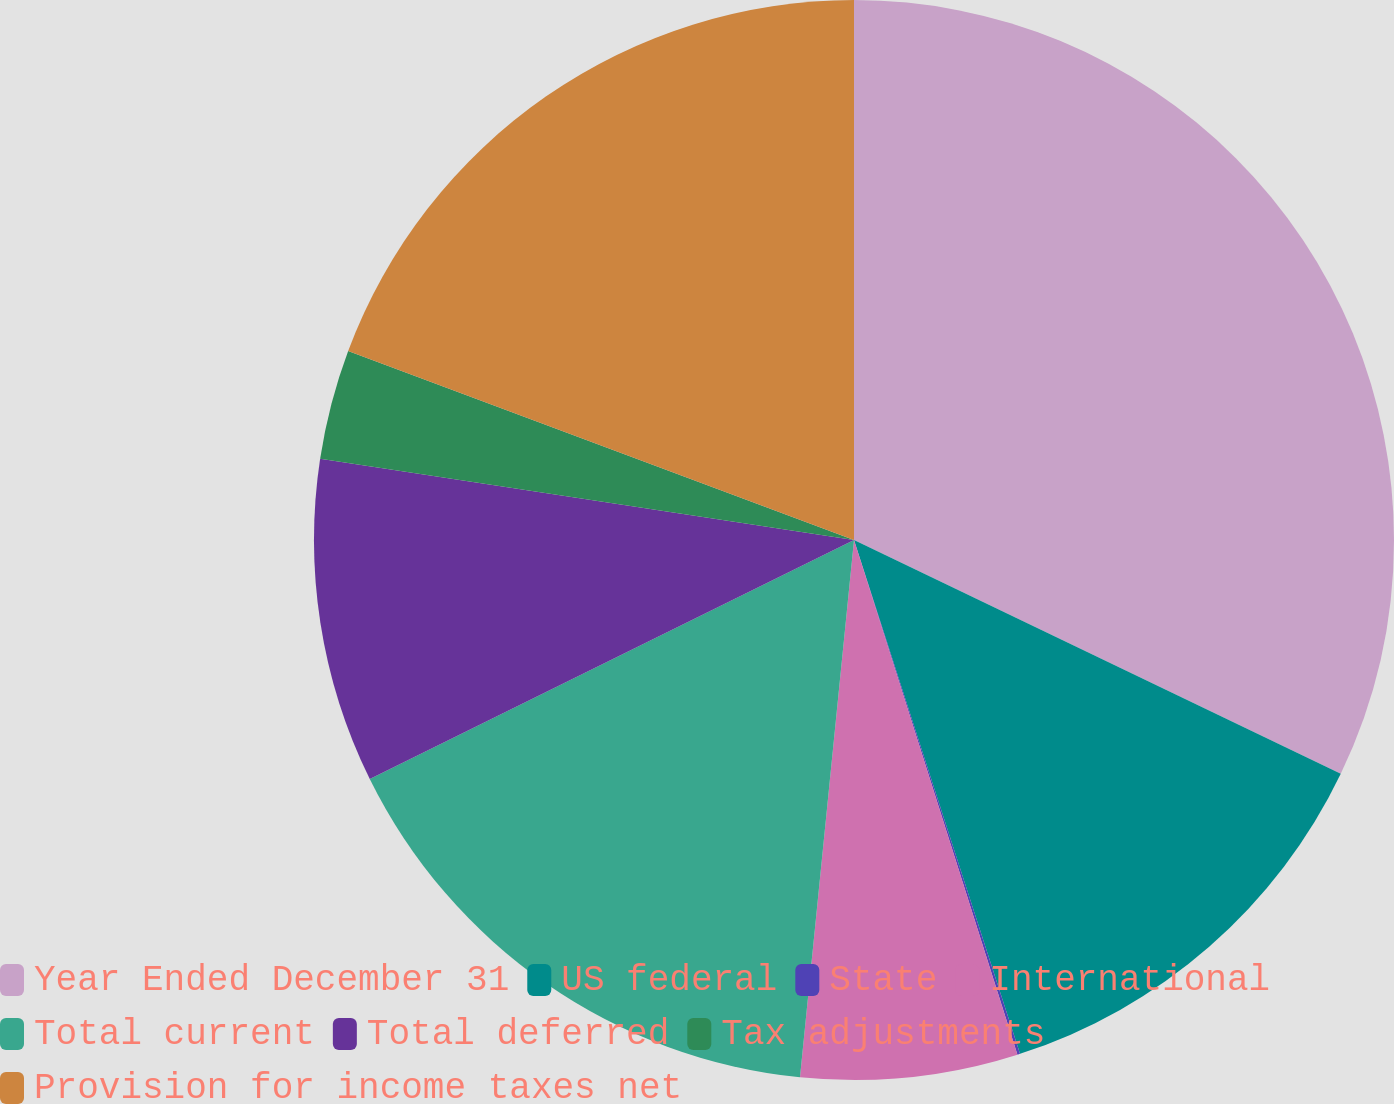Convert chart. <chart><loc_0><loc_0><loc_500><loc_500><pie_chart><fcel>Year Ended December 31<fcel>US federal<fcel>State<fcel>International<fcel>Total current<fcel>Total deferred<fcel>Tax adjustments<fcel>Provision for income taxes net<nl><fcel>32.13%<fcel>12.9%<fcel>0.08%<fcel>6.49%<fcel>16.11%<fcel>9.7%<fcel>3.29%<fcel>19.31%<nl></chart> 